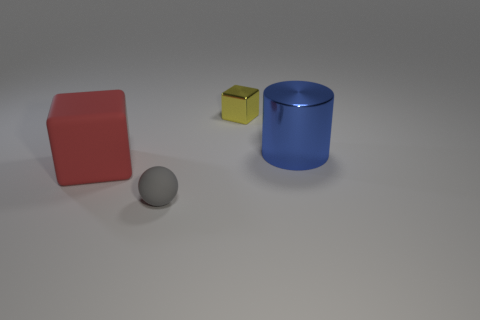The small thing that is made of the same material as the big block is what shape?
Keep it short and to the point. Sphere. There is a large thing left of the matte object that is on the right side of the red rubber thing that is left of the shiny cylinder; what is its color?
Make the answer very short. Red. There is a shiny cylinder; is its color the same as the object on the left side of the small rubber sphere?
Offer a very short reply. No. There is a metal thing that is in front of the block that is behind the large blue metal object; are there any blue metal things in front of it?
Ensure brevity in your answer.  No. How big is the thing that is behind the red thing and in front of the tiny shiny block?
Offer a very short reply. Large. There is a shiny object that is to the right of the yellow cube; does it have the same shape as the large red matte object?
Keep it short and to the point. No. How big is the cube on the left side of the block that is behind the blue metal cylinder right of the rubber ball?
Offer a very short reply. Large. The thing that is in front of the large blue cylinder and behind the matte ball has what shape?
Make the answer very short. Cube. There is a large metal thing; does it have the same shape as the rubber object that is to the right of the large block?
Keep it short and to the point. No. Does the red thing have the same shape as the yellow thing?
Offer a very short reply. Yes. 